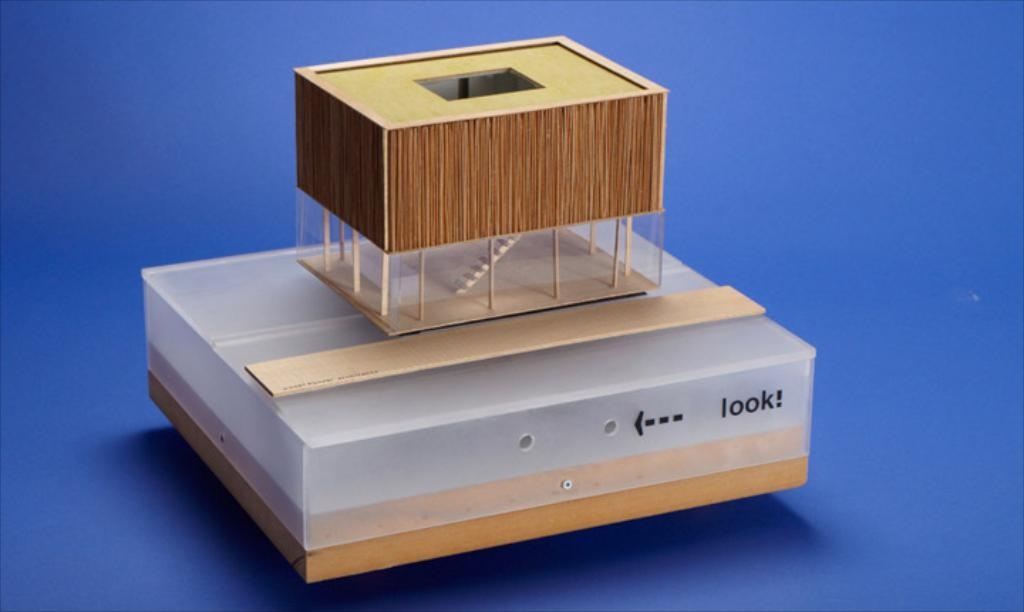<image>
Relay a brief, clear account of the picture shown. A plastic box with "look" written next to a peep hole with a ruler and small box on top of it. 